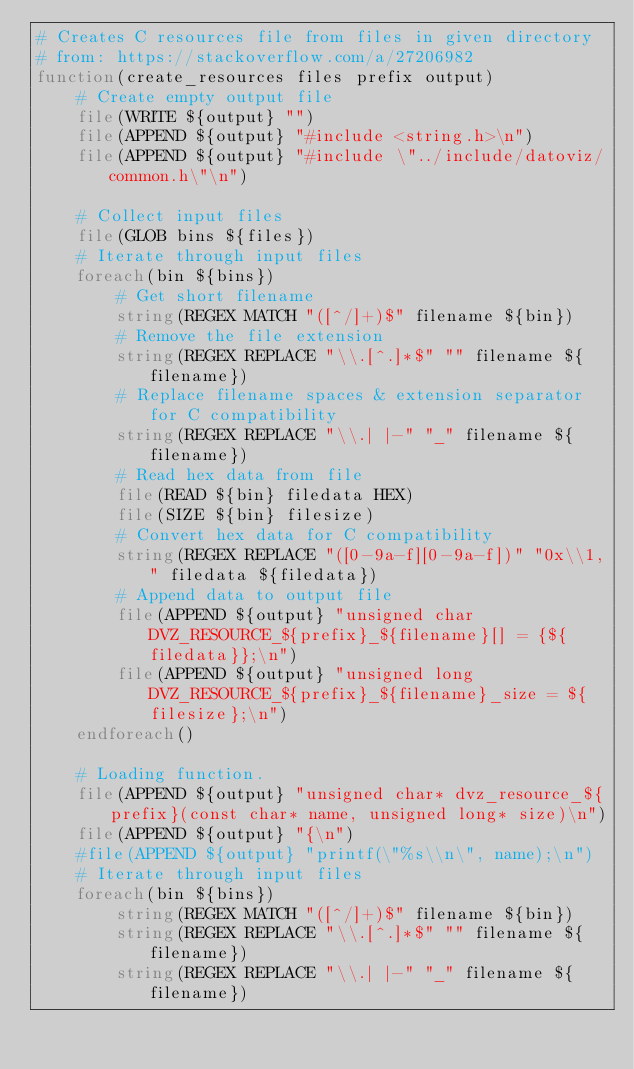<code> <loc_0><loc_0><loc_500><loc_500><_CMake_># Creates C resources file from files in given directory
# from: https://stackoverflow.com/a/27206982
function(create_resources files prefix output)
    # Create empty output file
    file(WRITE ${output} "")
    file(APPEND ${output} "#include <string.h>\n")
    file(APPEND ${output} "#include \"../include/datoviz/common.h\"\n")

    # Collect input files
    file(GLOB bins ${files})
    # Iterate through input files
    foreach(bin ${bins})
        # Get short filename
        string(REGEX MATCH "([^/]+)$" filename ${bin})
        # Remove the file extension
        string(REGEX REPLACE "\\.[^.]*$" "" filename ${filename})
        # Replace filename spaces & extension separator for C compatibility
        string(REGEX REPLACE "\\.| |-" "_" filename ${filename})
        # Read hex data from file
        file(READ ${bin} filedata HEX)
        file(SIZE ${bin} filesize)
        # Convert hex data for C compatibility
        string(REGEX REPLACE "([0-9a-f][0-9a-f])" "0x\\1," filedata ${filedata})
        # Append data to output file
        file(APPEND ${output} "unsigned char DVZ_RESOURCE_${prefix}_${filename}[] = {${filedata}};\n")
        file(APPEND ${output} "unsigned long DVZ_RESOURCE_${prefix}_${filename}_size = ${filesize};\n")
    endforeach()

    # Loading function.
    file(APPEND ${output} "unsigned char* dvz_resource_${prefix}(const char* name, unsigned long* size)\n")
    file(APPEND ${output} "{\n")
    #file(APPEND ${output} "printf(\"%s\\n\", name);\n")
    # Iterate through input files
    foreach(bin ${bins})
        string(REGEX MATCH "([^/]+)$" filename ${bin})
        string(REGEX REPLACE "\\.[^.]*$" "" filename ${filename})
        string(REGEX REPLACE "\\.| |-" "_" filename ${filename})</code> 